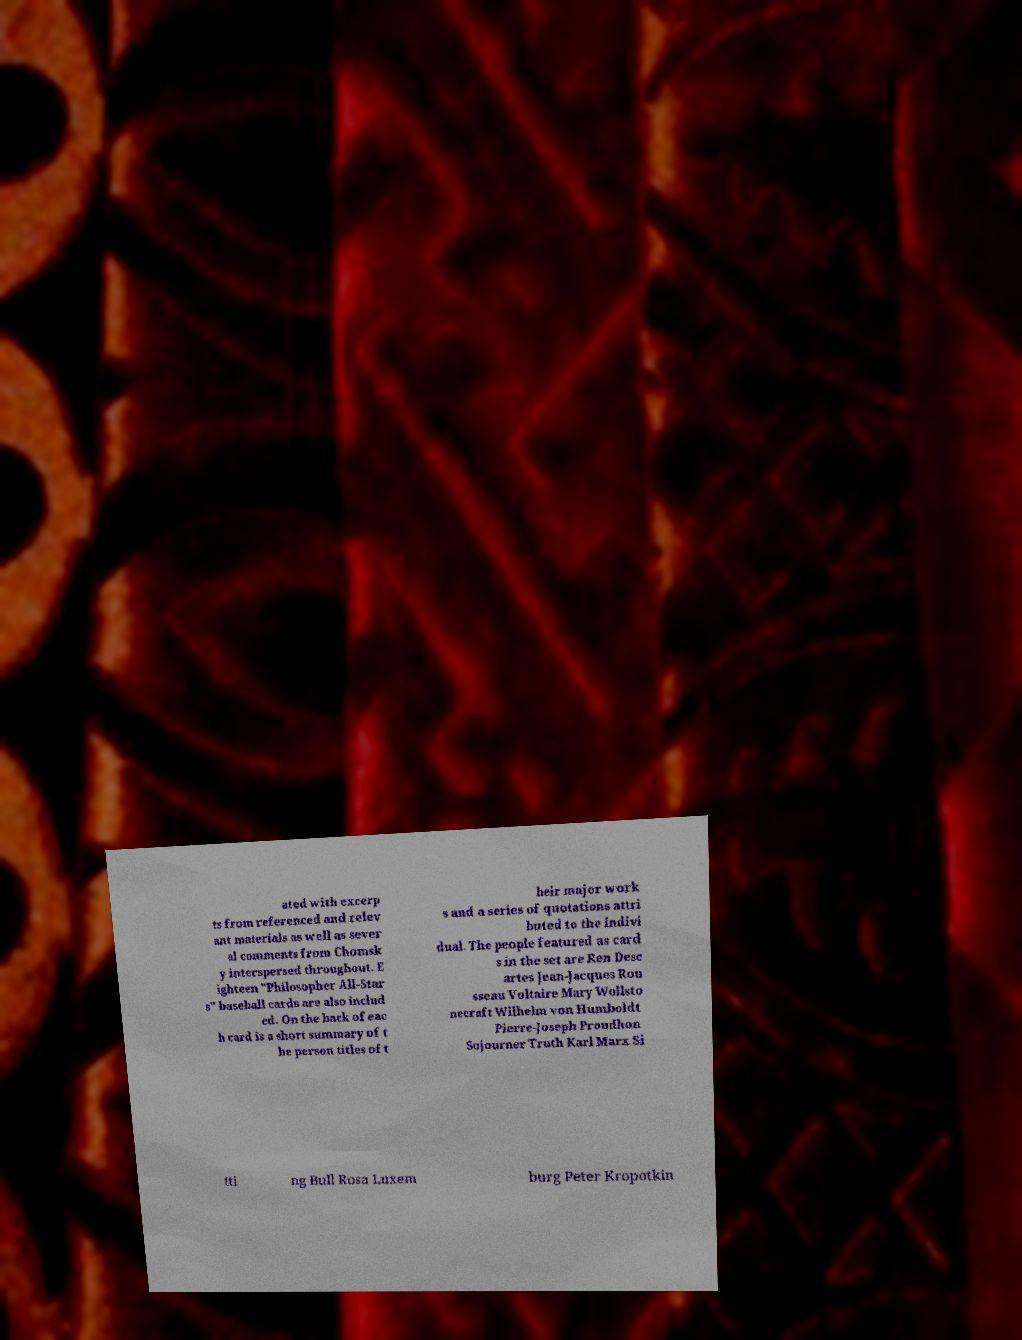Could you assist in decoding the text presented in this image and type it out clearly? ated with excerp ts from referenced and relev ant materials as well as sever al comments from Chomsk y interspersed throughout. E ighteen "Philosopher All-Star s" baseball cards are also includ ed. On the back of eac h card is a short summary of t he person titles of t heir major work s and a series of quotations attri buted to the indivi dual. The people featured as card s in the set are Ren Desc artes Jean-Jacques Rou sseau Voltaire Mary Wollsto necraft Wilhelm von Humboldt Pierre-Joseph Proudhon Sojourner Truth Karl Marx Si tti ng Bull Rosa Luxem burg Peter Kropotkin 